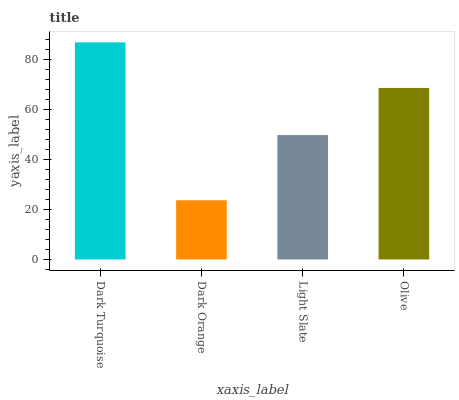Is Light Slate the minimum?
Answer yes or no. No. Is Light Slate the maximum?
Answer yes or no. No. Is Light Slate greater than Dark Orange?
Answer yes or no. Yes. Is Dark Orange less than Light Slate?
Answer yes or no. Yes. Is Dark Orange greater than Light Slate?
Answer yes or no. No. Is Light Slate less than Dark Orange?
Answer yes or no. No. Is Olive the high median?
Answer yes or no. Yes. Is Light Slate the low median?
Answer yes or no. Yes. Is Dark Turquoise the high median?
Answer yes or no. No. Is Dark Turquoise the low median?
Answer yes or no. No. 